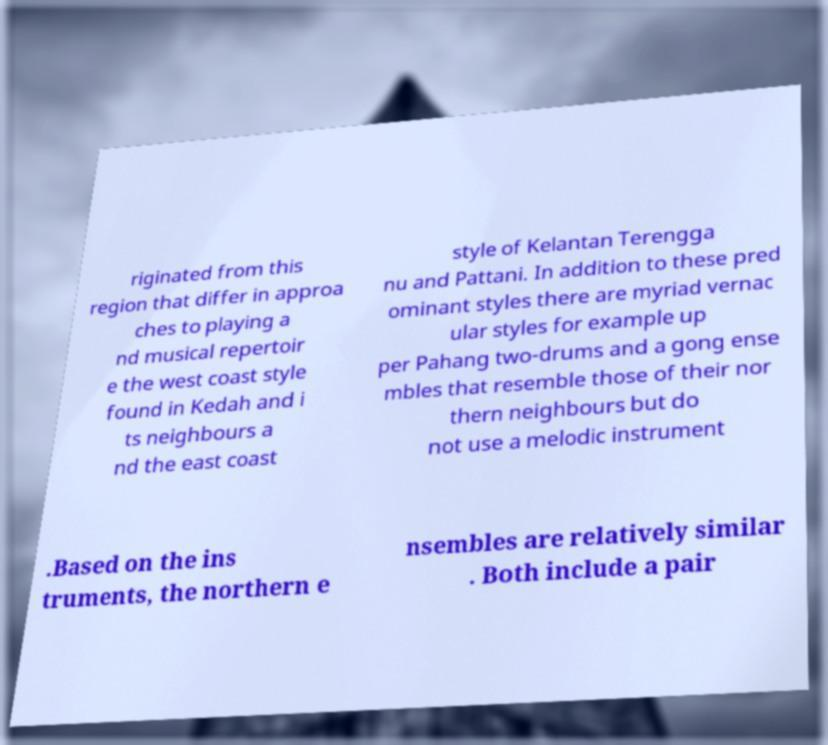Please read and relay the text visible in this image. What does it say? riginated from this region that differ in approa ches to playing a nd musical repertoir e the west coast style found in Kedah and i ts neighbours a nd the east coast style of Kelantan Terengga nu and Pattani. In addition to these pred ominant styles there are myriad vernac ular styles for example up per Pahang two-drums and a gong ense mbles that resemble those of their nor thern neighbours but do not use a melodic instrument .Based on the ins truments, the northern e nsembles are relatively similar . Both include a pair 